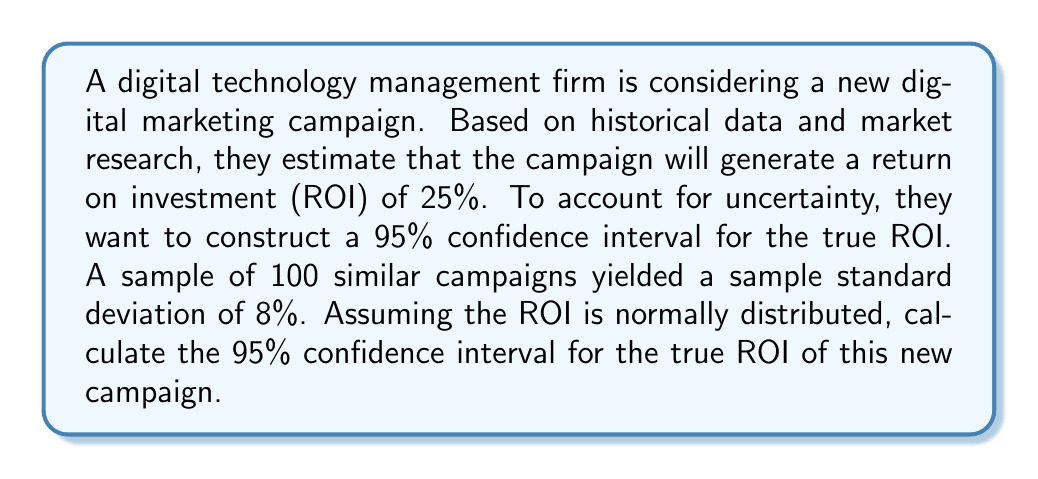What is the answer to this math problem? To solve this problem, we'll use the formula for a confidence interval of a population mean:

$$\text{CI} = \bar{x} \pm z_{\alpha/2} \cdot \frac{\sigma}{\sqrt{n}}$$

Where:
$\bar{x}$ = sample mean (estimated ROI)
$z_{\alpha/2}$ = z-score for the desired confidence level
$\sigma$ = population standard deviation
$n$ = sample size

Step 1: Identify the given information
- Estimated ROI ($\bar{x}$) = 25%
- Sample size ($n$) = 100
- Sample standard deviation ($s$) = 8%
- Confidence level = 95%

Step 2: Find the z-score for a 95% confidence interval
For a 95% confidence interval, $z_{\alpha/2} = 1.96$

Step 3: Calculate the margin of error
Margin of error = $z_{\alpha/2} \cdot \frac{\sigma}{\sqrt{n}}$

Note: We're using the sample standard deviation ($s$) as an estimate of the population standard deviation ($\sigma$).

$$\text{Margin of error} = 1.96 \cdot \frac{8\%}{\sqrt{100}} = 1.96 \cdot 0.8\% = 1.568\%$$

Step 4: Calculate the confidence interval
Lower bound = $\bar{x} - \text{Margin of error} = 25\% - 1.568\% = 23.432\%$
Upper bound = $\bar{x} + \text{Margin of error} = 25\% + 1.568\% = 26.568\%$

Therefore, the 95% confidence interval for the true ROI is (23.432%, 26.568%).
Answer: The 95% confidence interval for the true ROI of the new digital marketing campaign is (23.432%, 26.568%). 